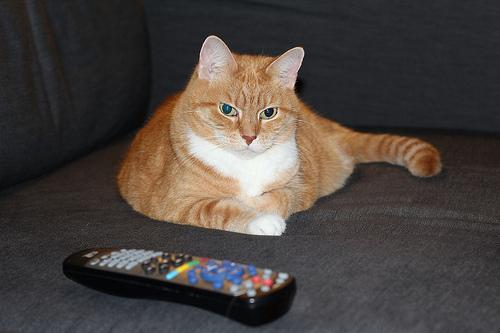Describe the primary electronic device shown in the image and its nearby elements. A long, black remote control with colored buttons is sitting in front of the cat on the couch. Briefly describe the scene involving the cat and electronic device. An orange and white cat is lying down on a grey couch, looking at a black remote control in front of it. Briefly describe the main object on the couch and any additional nearby object. A large orange cat is reclining on a grey cushion, with a black remote control positioned close to it. Mention one notable feature of the cat in the image. The cat has large, gold eyes and a white fur front. Mention the primary colors of the buttons on the remote control. The buttons on the remote control are blue, white, and grey. What is a striking characteristic of the cat's eyes? The cat's eyes are almond-shaped and yellow in color. Provide a brief description of the most prominent animal in the image. A large orange and white cat is reclining on a couch with its striped tail curled beside it. What is the cat doing in the scene? The cat is laying down on a couch, looking at a remote control in front of it. Describe the cat's position in relation to the couch. The large orange cat is reclining on the sofa, facing the remote control. Point out a distinctive aspect of the cat's tail. The cat's tail is long, striped, and orange in color. 